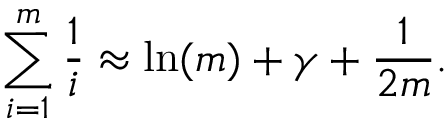Convert formula to latex. <formula><loc_0><loc_0><loc_500><loc_500>\sum _ { i = 1 } ^ { m } { \frac { 1 } { i } } \approx \ln ( m ) + \gamma + { \frac { 1 } { 2 m } } .</formula> 